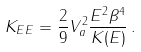<formula> <loc_0><loc_0><loc_500><loc_500>K _ { E E } = \frac { 2 } { 9 } V _ { a } ^ { 2 } \frac { E ^ { 2 } \beta ^ { 4 } } { K ( E ) } \, .</formula> 